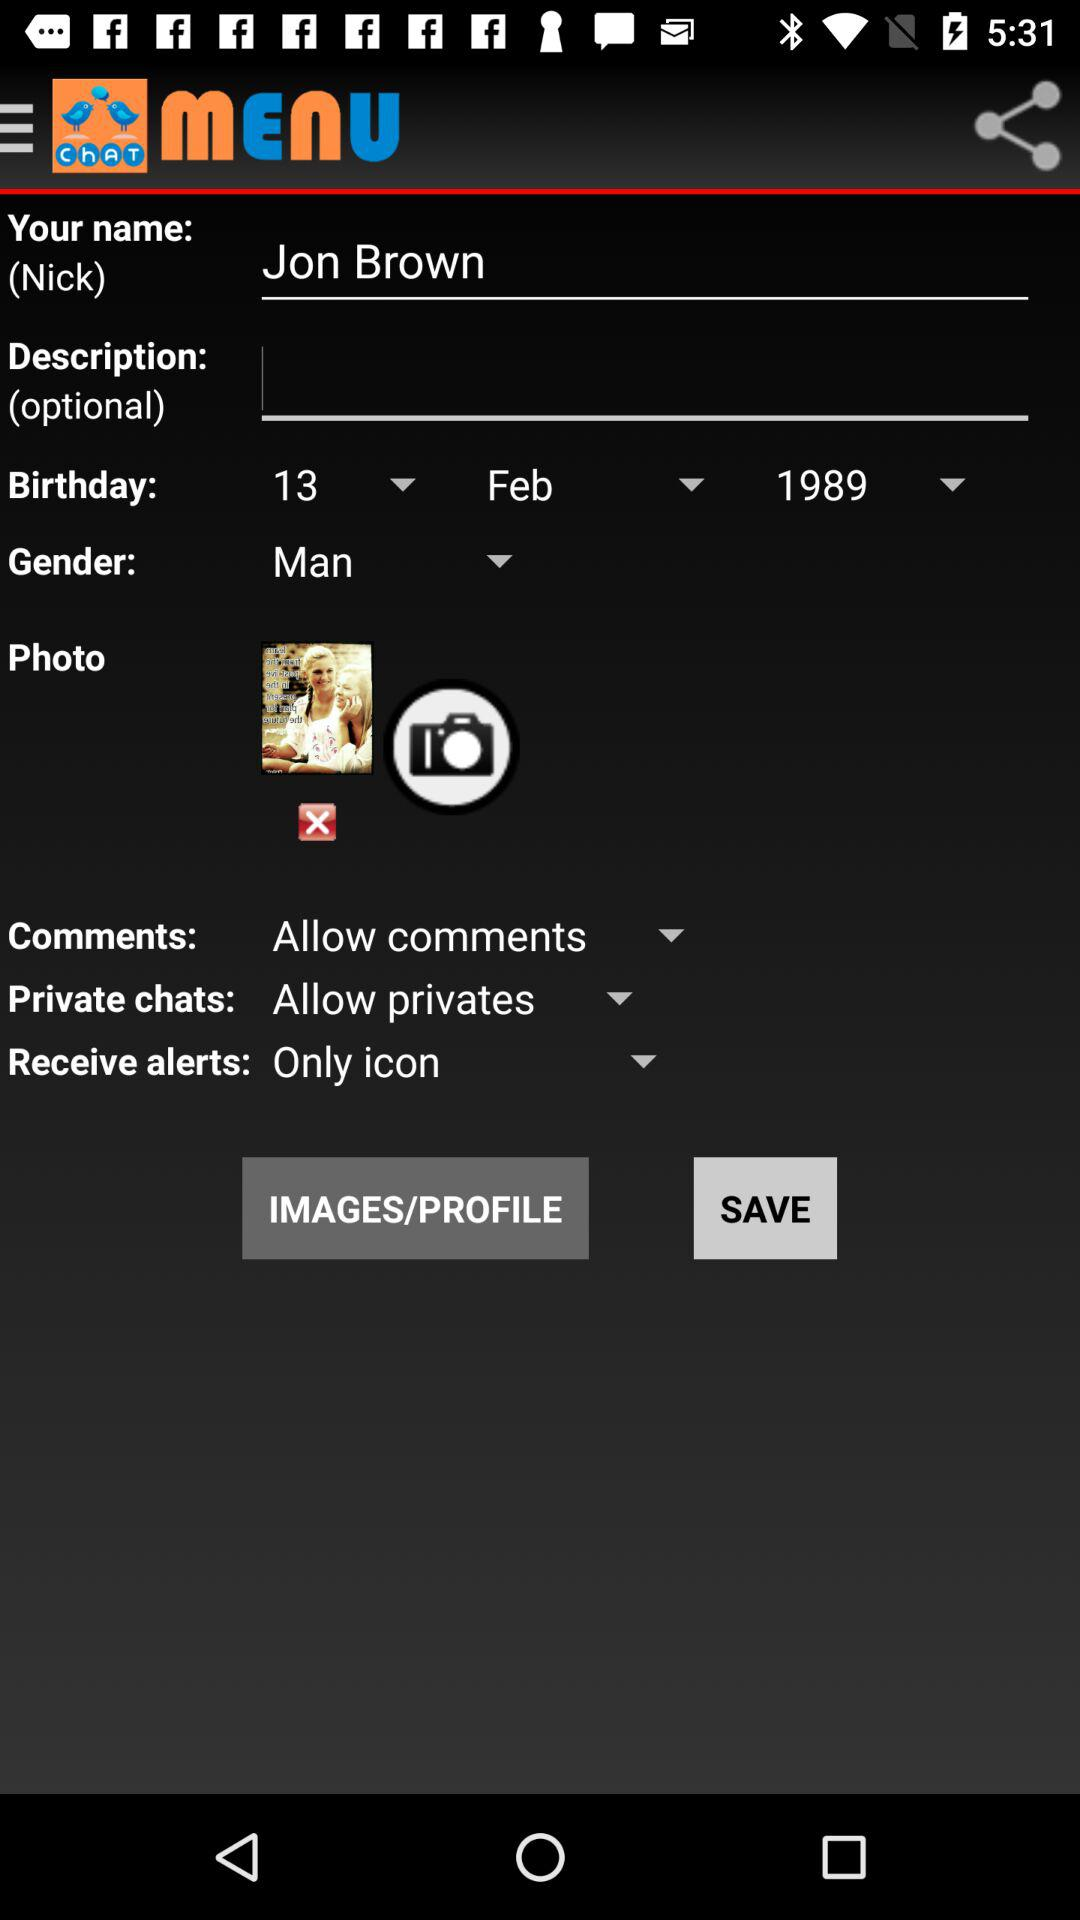What is the date of birth? The date of birth is February 13, 1989. 